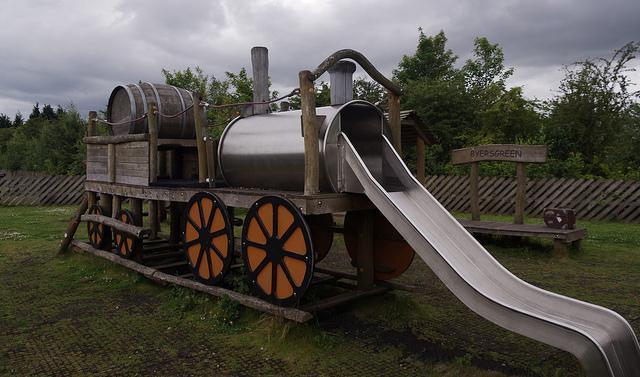How many tennis balls are present in this picture?
Give a very brief answer. 0. How many carrots are there?
Give a very brief answer. 0. 